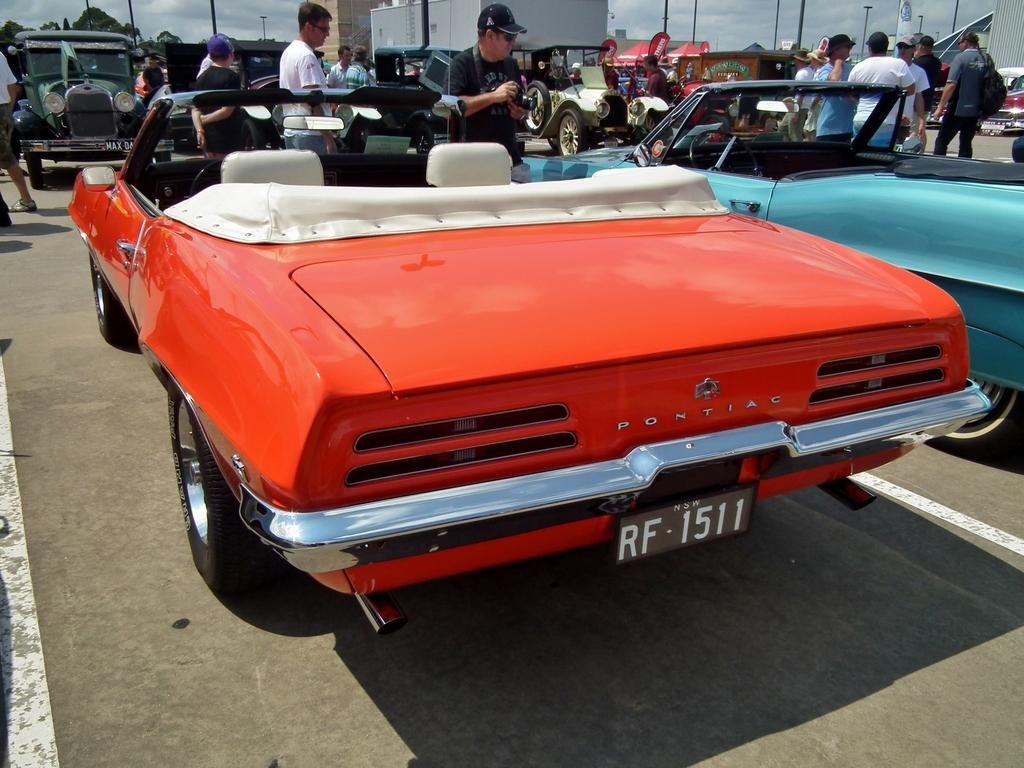What is the main subject of the image? There is a group of people in the image. What else can be seen in the image besides the group of people? There are vehicles on the road and poles, trees, and the sky visible in the background of the image. What type of books are the people reading in the image? There are no books present in the image; it features a group of people and other elements such as vehicles, poles, trees, and the sky. 